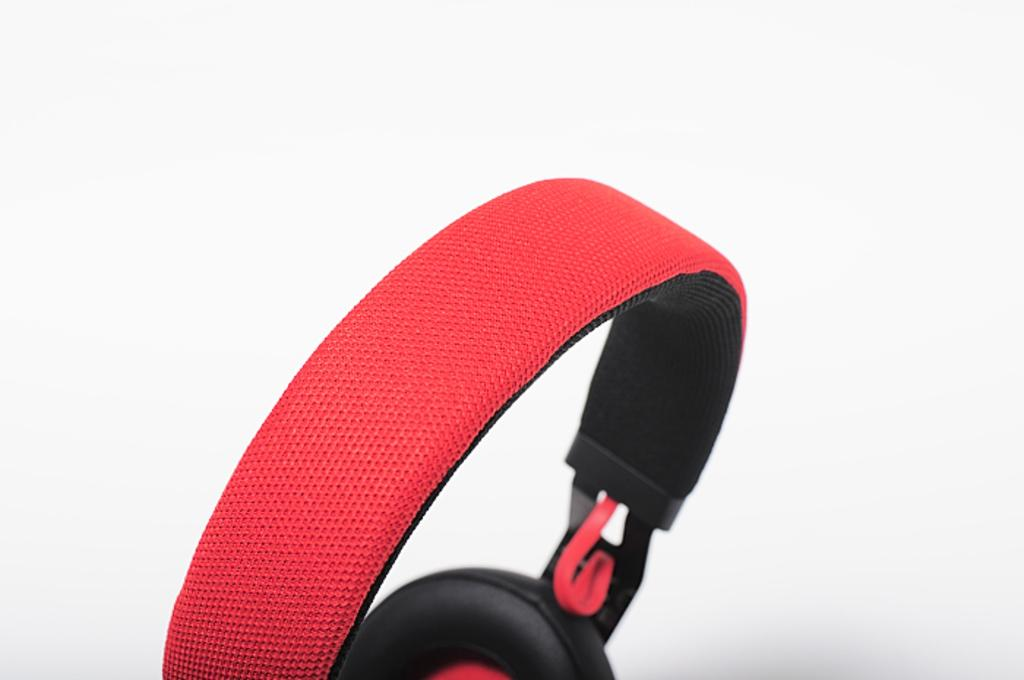What is the main object in the image? There is a headset in the image. What colors is the headset in the image? The headset is in black and red color. What type of record can be seen being played on the headset in the image? There is no record present in the image, as the headset is an audio device and does not play records. What type of watch is visible on the person's wrist in the image? There is no watch visible in the image; only the headset is mentioned. What type of meal is being prepared in the image? There is no meal preparation visible in the image; only the headset is mentioned. 